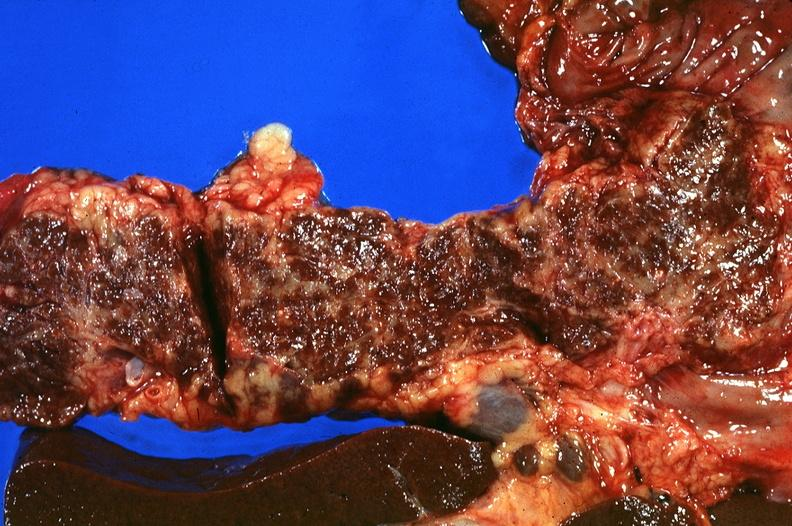does this image show pancreas, hemochromatosis?
Answer the question using a single word or phrase. Yes 